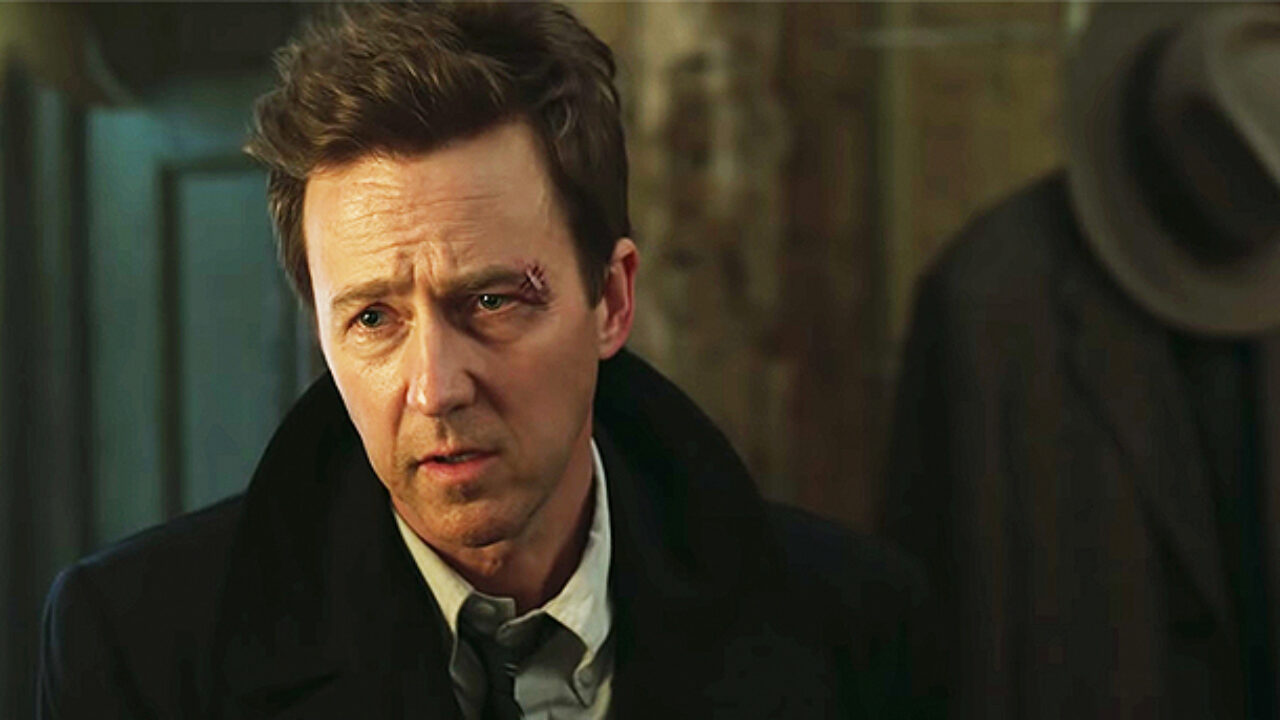How does the lighting affect the mood of this scene? The lighting in the scene is dim with focused illumination on the character's face, enhancing the gravity and intensity of his expression. This kind of lighting technique often signifies tension, uncertainty, or an impending difficult decision, which aligns with the serious and contemplative mood conveyed by the character's demeanor. 